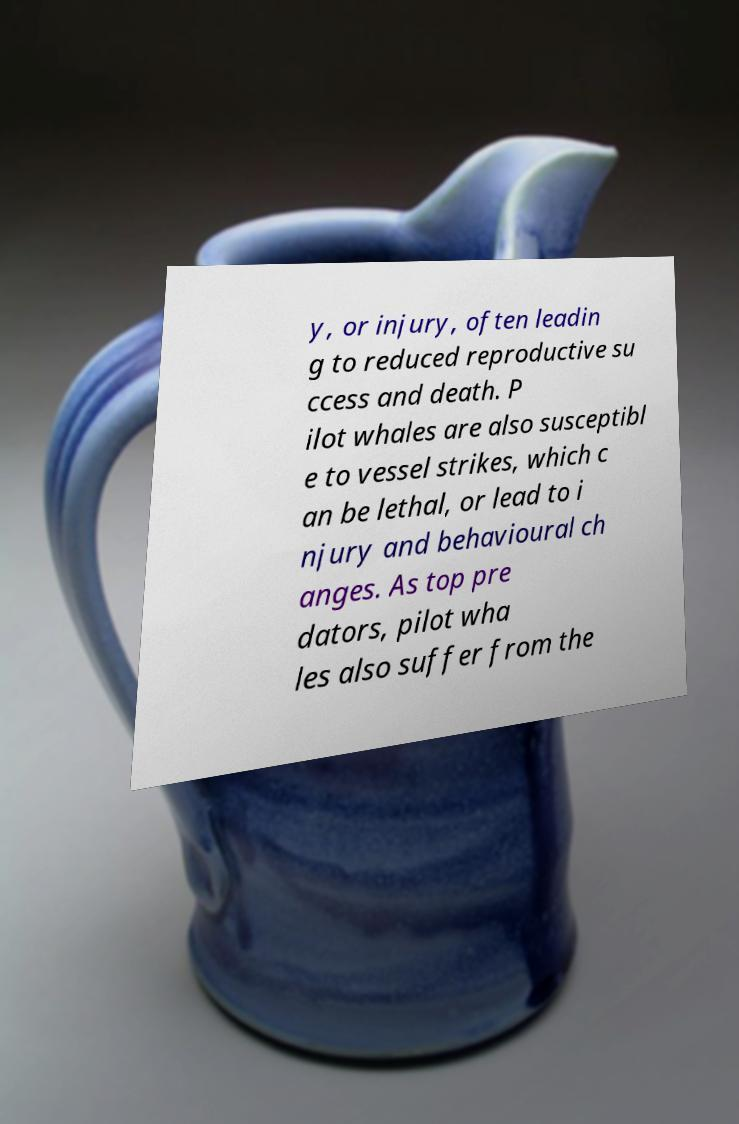Could you assist in decoding the text presented in this image and type it out clearly? y, or injury, often leadin g to reduced reproductive su ccess and death. P ilot whales are also susceptibl e to vessel strikes, which c an be lethal, or lead to i njury and behavioural ch anges. As top pre dators, pilot wha les also suffer from the 